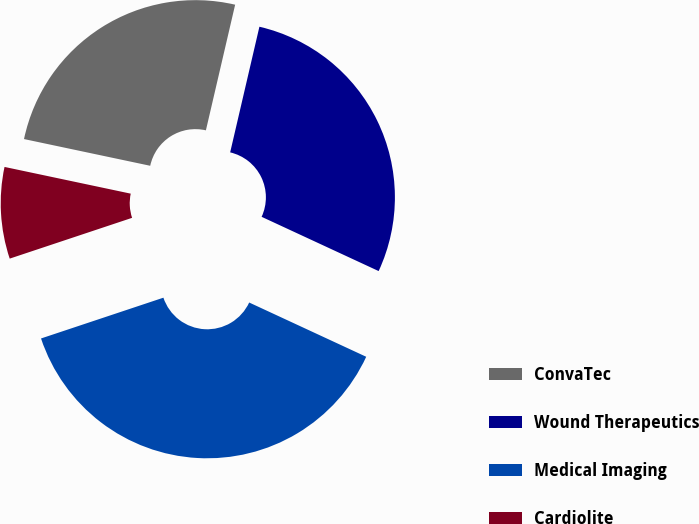<chart> <loc_0><loc_0><loc_500><loc_500><pie_chart><fcel>ConvaTec<fcel>Wound Therapeutics<fcel>Medical Imaging<fcel>Cardiolite<nl><fcel>25.32%<fcel>28.27%<fcel>37.97%<fcel>8.44%<nl></chart> 